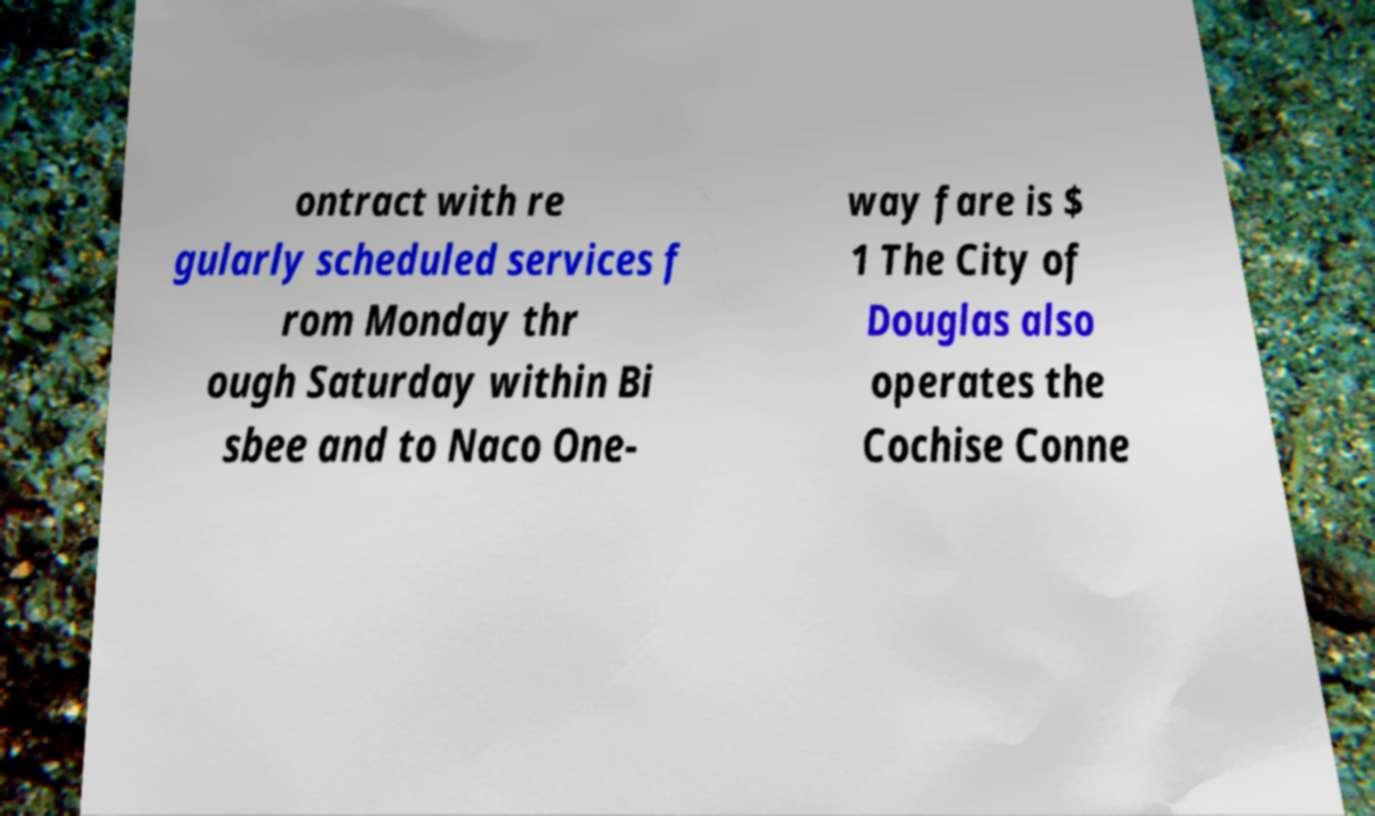Please identify and transcribe the text found in this image. ontract with re gularly scheduled services f rom Monday thr ough Saturday within Bi sbee and to Naco One- way fare is $ 1 The City of Douglas also operates the Cochise Conne 